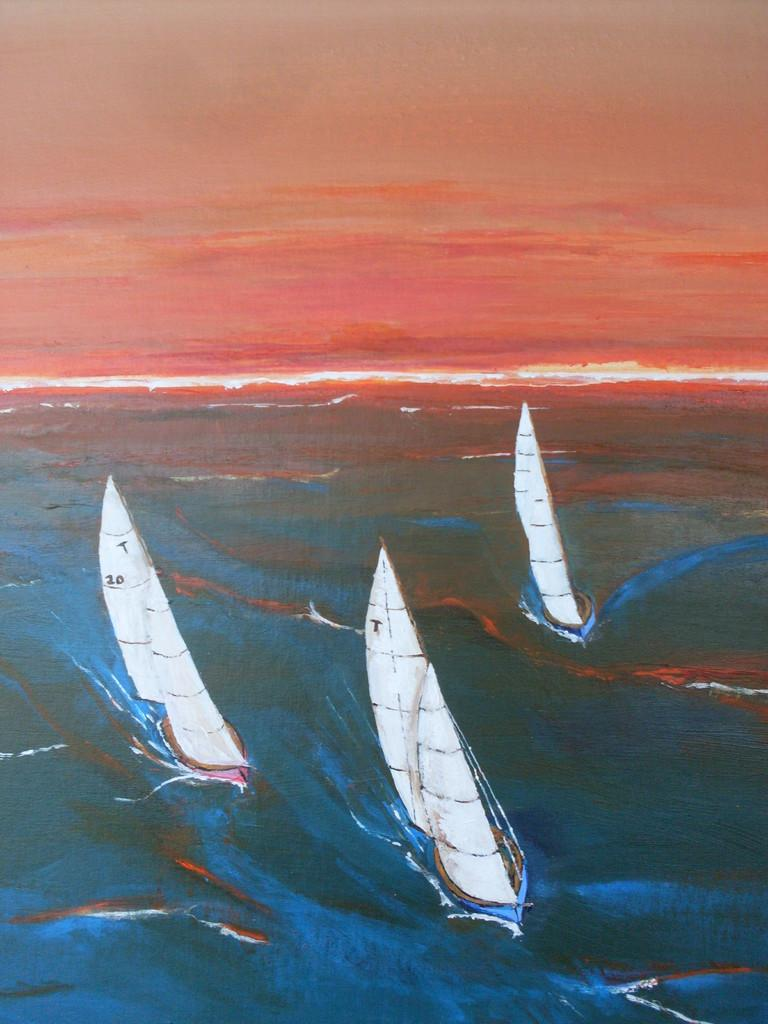<image>
Offer a succinct explanation of the picture presented. White sail ships with one of the sails that says 20 on it. 